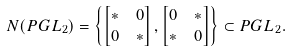<formula> <loc_0><loc_0><loc_500><loc_500>N ( P G L _ { 2 } ) & = \left \{ \begin{bmatrix} * & 0 \\ 0 & * \\ \end{bmatrix} , \begin{bmatrix} 0 & * \\ * & 0 \\ \end{bmatrix} \right \} \subset P G L _ { 2 } .</formula> 